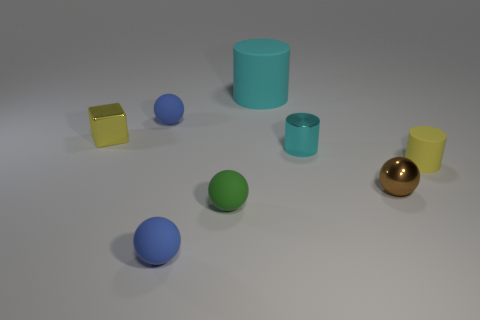Imagine these objects convey a concept in a minimalist art piece, what could that be? The arrangement of simple geometric shapes with varying colors might symbolize the diversity and unity in society. Each object maintains its unique color and shape, yet they coexist harmoniously within the same space. 